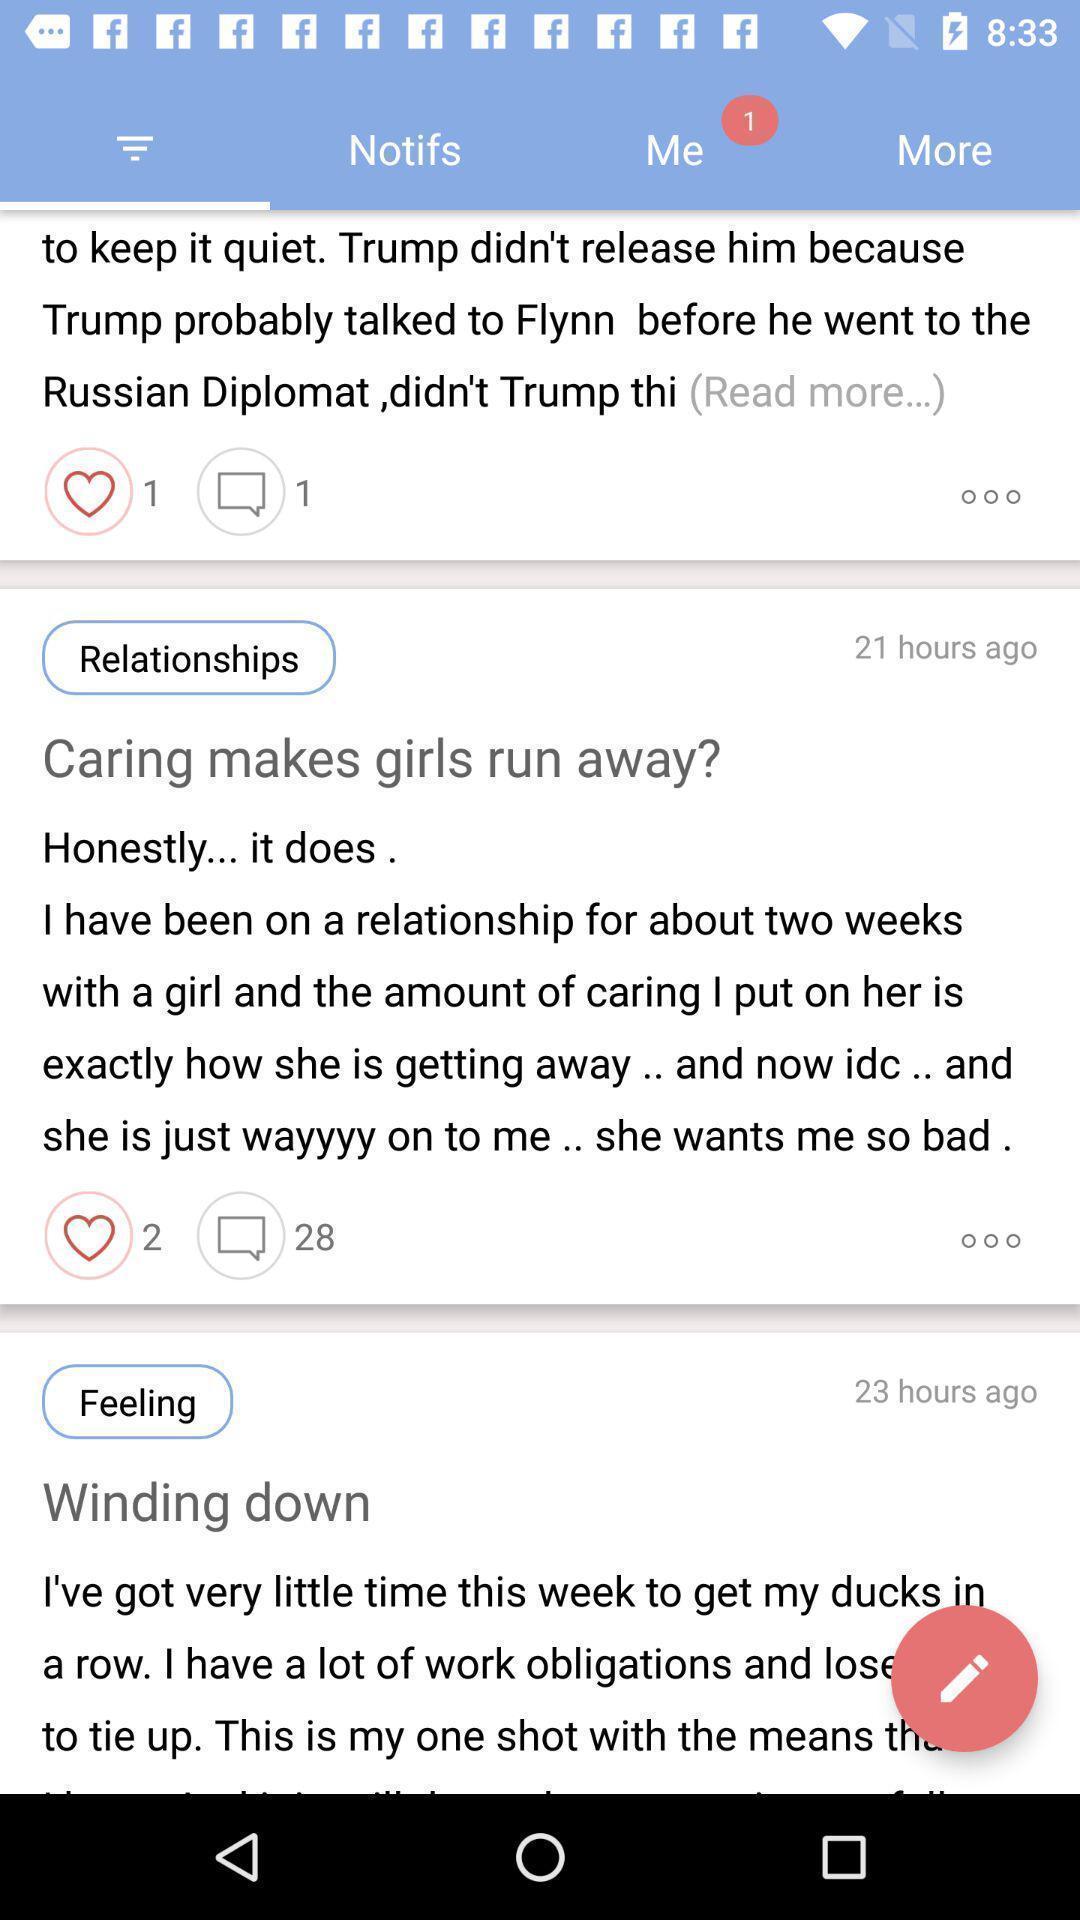What is the overall content of this screenshot? Various posts. 